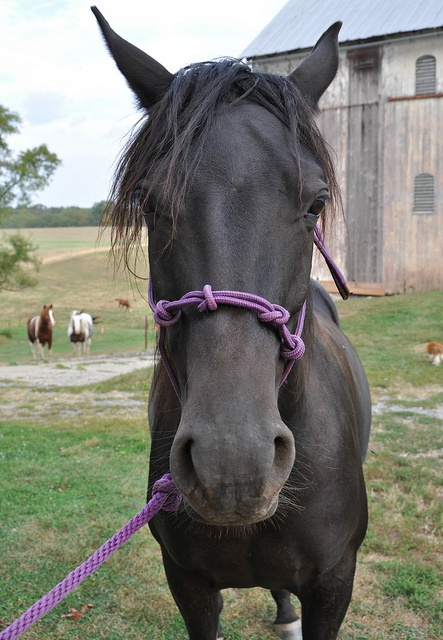Describe the objects in this image and their specific colors. I can see horse in white, gray, and black tones, horse in white, darkgray, maroon, black, and gray tones, horse in white, darkgray, lightgray, gray, and black tones, and horse in white, gray, tan, and brown tones in this image. 